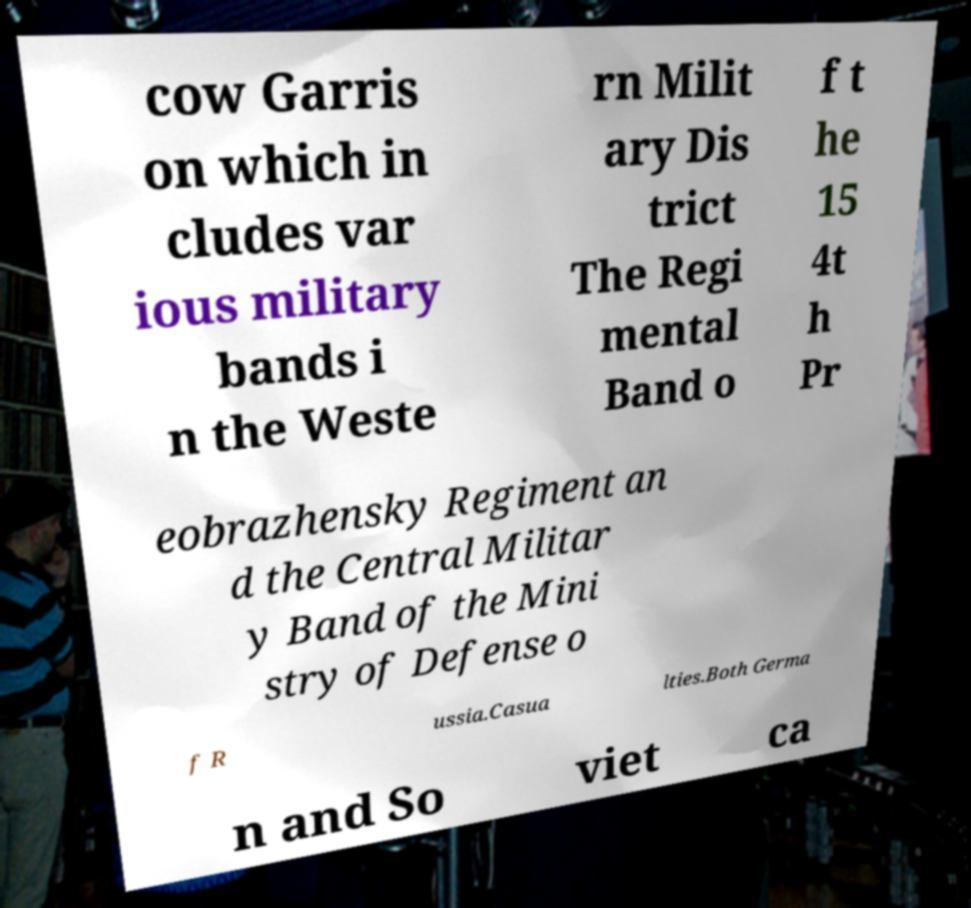Please read and relay the text visible in this image. What does it say? cow Garris on which in cludes var ious military bands i n the Weste rn Milit ary Dis trict The Regi mental Band o f t he 15 4t h Pr eobrazhensky Regiment an d the Central Militar y Band of the Mini stry of Defense o f R ussia.Casua lties.Both Germa n and So viet ca 